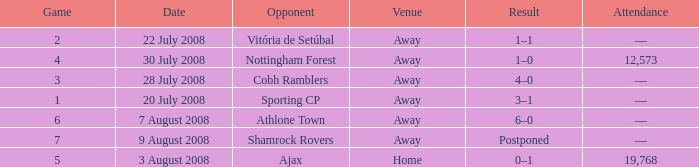What is the total game number with athlone town as the opponent? 1.0. 